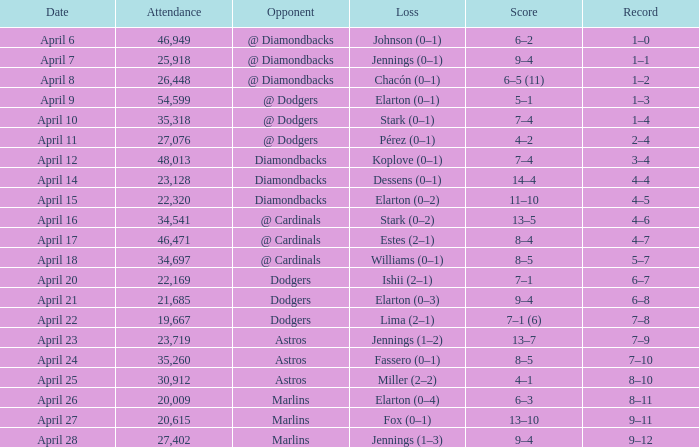Name the score when the opponent was the dodgers on april 21 9–4. 